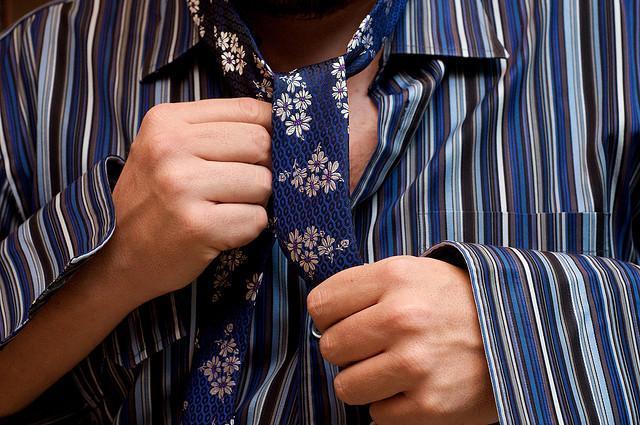How many people are in the photo?
Give a very brief answer. 1. How many ties are in the picture?
Give a very brief answer. 1. How many train cars are on the right of the man ?
Give a very brief answer. 0. 